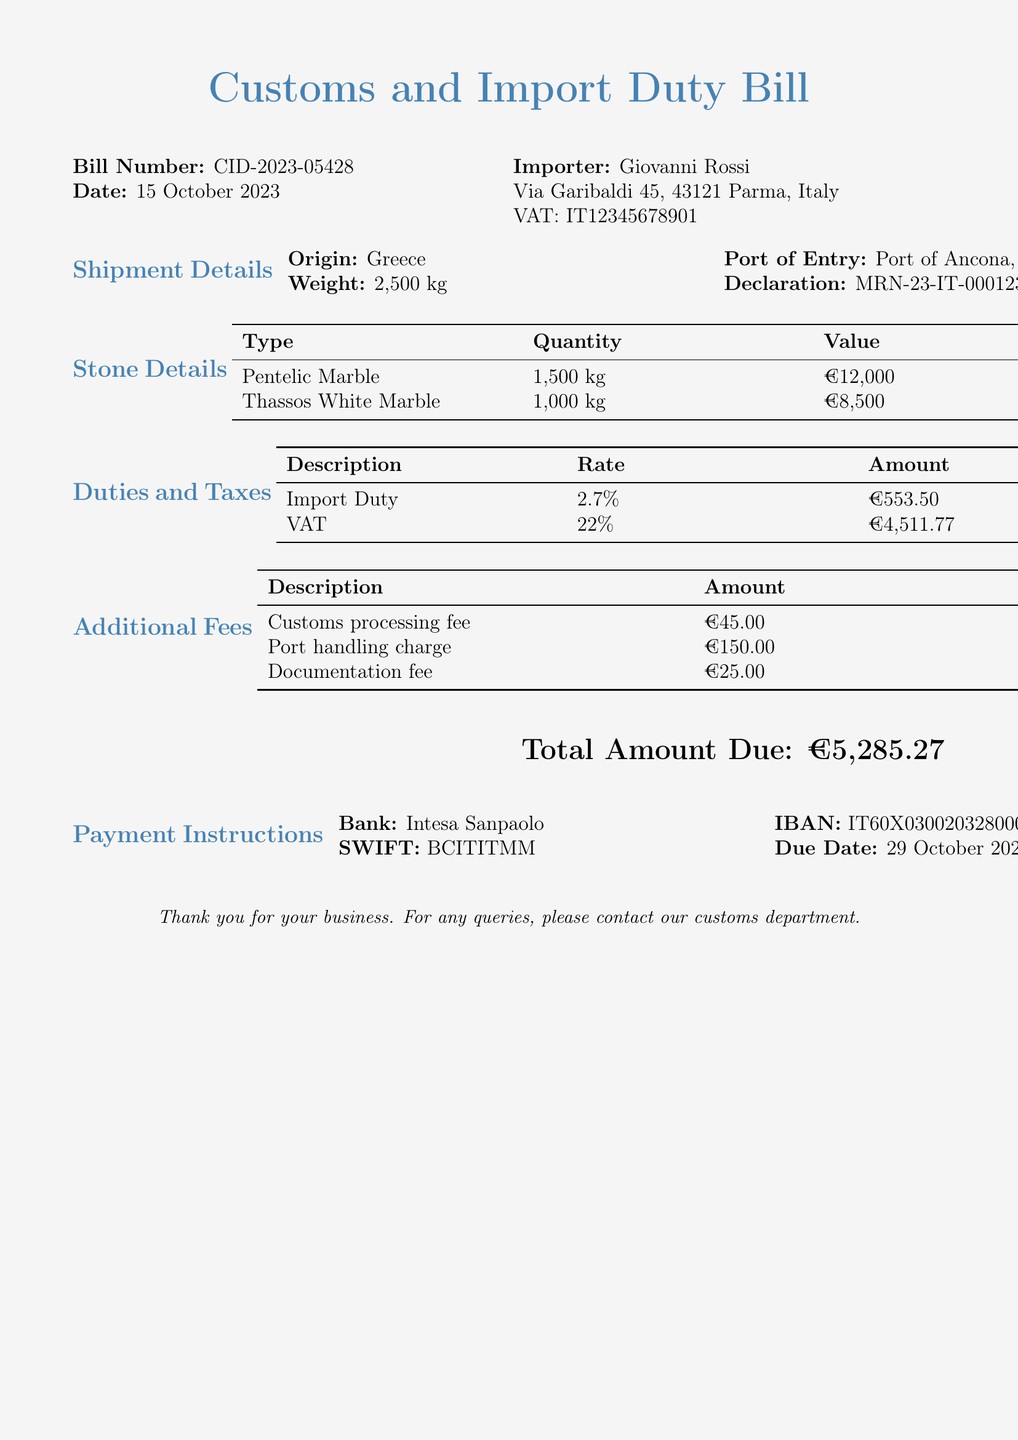What is the bill number? The bill number is prominently displayed in the document as a unique identifier for this specific transaction.
Answer: CID-2023-05428 What is the date of the bill? The date signifies when the bill was issued and is listed right under the bill number.
Answer: 15 October 2023 Who is the importer? The document specifies the name and VAT number of the person receiving the shipment.
Answer: Giovanni Rossi What is the total amount due? The total amount due is clearly stated at the bottom of the document, summarizing all charges.
Answer: €5,285.27 What type of marble has the highest value? This information can be inferred from the values listed for each type of stone in the document.
Answer: Pentelic Marble What is the VAT rate applied? The VAT rate is a specific percentage applied to the total value, and is referenced in the duties and taxes section.
Answer: 22% What is the due date for payment? The due date tells the importer when the payment for the bill needs to be made, which is mentioned in the payment instructions.
Answer: 29 October 2023 How much is the customs processing fee? The customs processing fee is listed under additional fees, directly indicating the cost for processing.
Answer: €45.00 What is the weight of the shipment? The weight of the shipment is stated in the shipment details section of the document.
Answer: 2,500 kg 